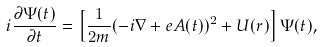<formula> <loc_0><loc_0><loc_500><loc_500>i \frac { \partial \Psi ( t ) } { \partial t } = \left [ \frac { 1 } { 2 m } ( - i { \nabla } + e { A } ( t ) ) ^ { 2 } + U ( { r } ) \right ] \Psi ( t ) ,</formula> 